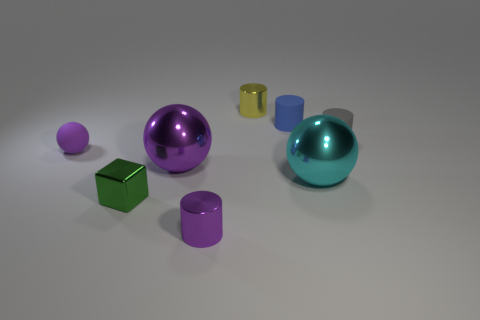What kind of lighting is used in this scene and how does it affect the appearance of the objects? The scene is lit with diffuse, soft light, possibly from an overhead source. This lighting creates subtle shadows and gentle highlights on the objects that enhance their three-dimensional appearance without causing harsh reflections or deep shadows. 